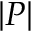Convert formula to latex. <formula><loc_0><loc_0><loc_500><loc_500>\left | P \right |</formula> 